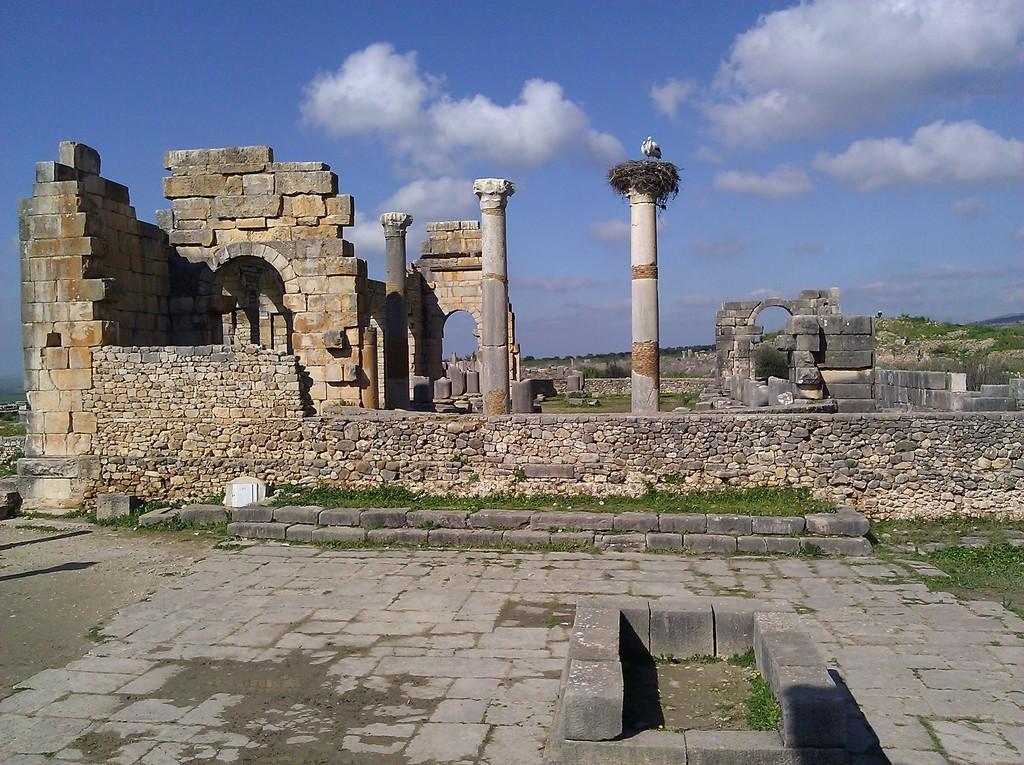Can you describe this image briefly? In this image I can see the ground, some grass, few walls which are made up of rocks and two pillars. On the pillar I can see a bird nest and birds standing. In the background I can see the sky. 